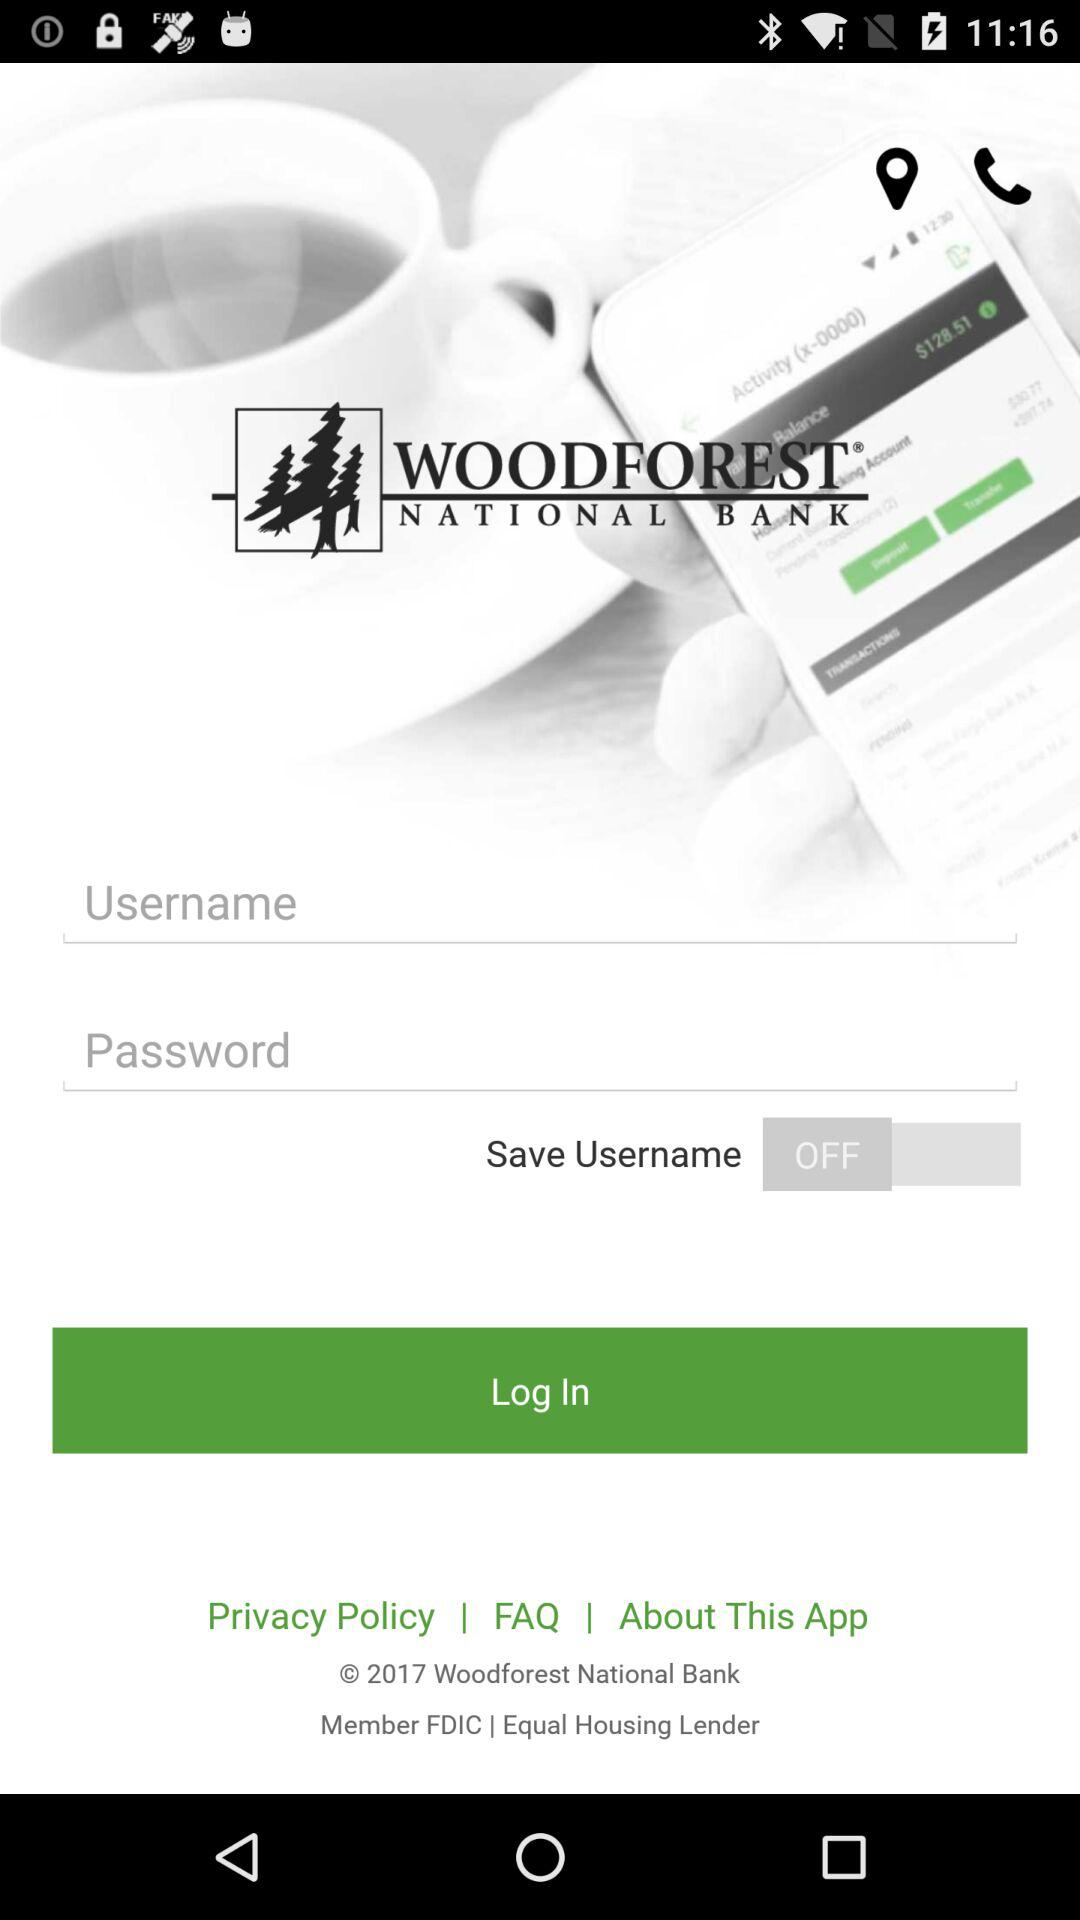What is the status of "Save Username"? The status is "off". 